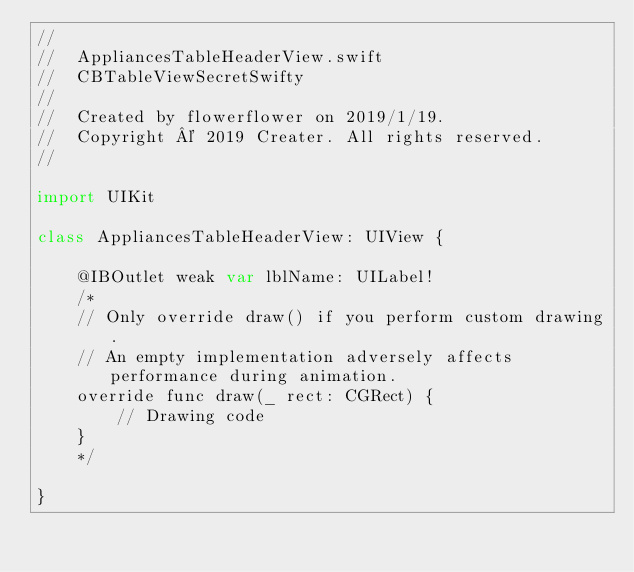Convert code to text. <code><loc_0><loc_0><loc_500><loc_500><_Swift_>//
//  AppliancesTableHeaderView.swift
//  CBTableViewSecretSwifty
//
//  Created by flowerflower on 2019/1/19.
//  Copyright © 2019 Creater. All rights reserved.
//

import UIKit

class AppliancesTableHeaderView: UIView {

    @IBOutlet weak var lblName: UILabel!
    /*
    // Only override draw() if you perform custom drawing.
    // An empty implementation adversely affects performance during animation.
    override func draw(_ rect: CGRect) {
        // Drawing code
    }
    */

}
</code> 